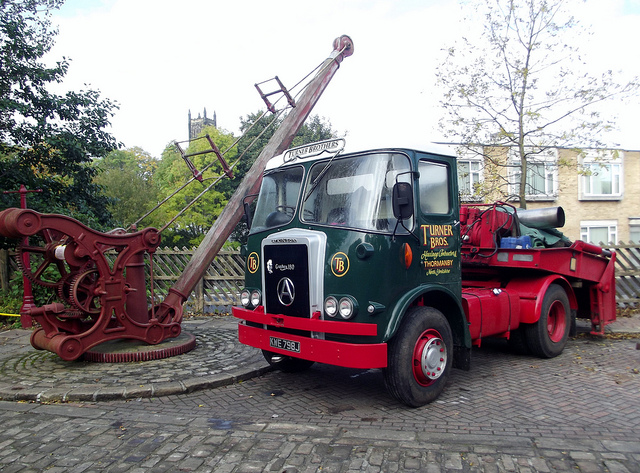Please extract the text content from this image. TB TB BROS 758 A 